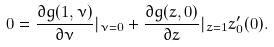<formula> <loc_0><loc_0><loc_500><loc_500>0 = \frac { \partial g ( 1 , \nu ) } { \partial \nu } | _ { \nu = 0 } + \frac { \partial g ( z , 0 ) } { \partial z } | _ { z = 1 } z _ { 0 } ^ { \prime } ( 0 ) .</formula> 